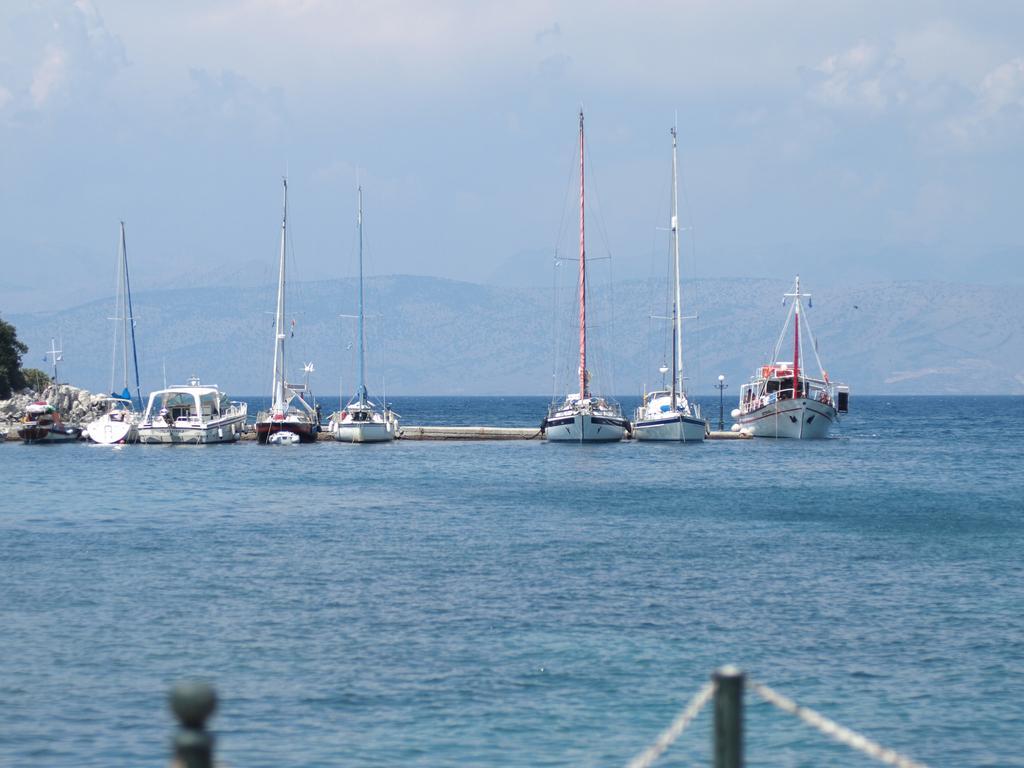Please provide a concise description of this image. Here we can see ships on the water. There are trees and a mountain. In the background there is sky. 